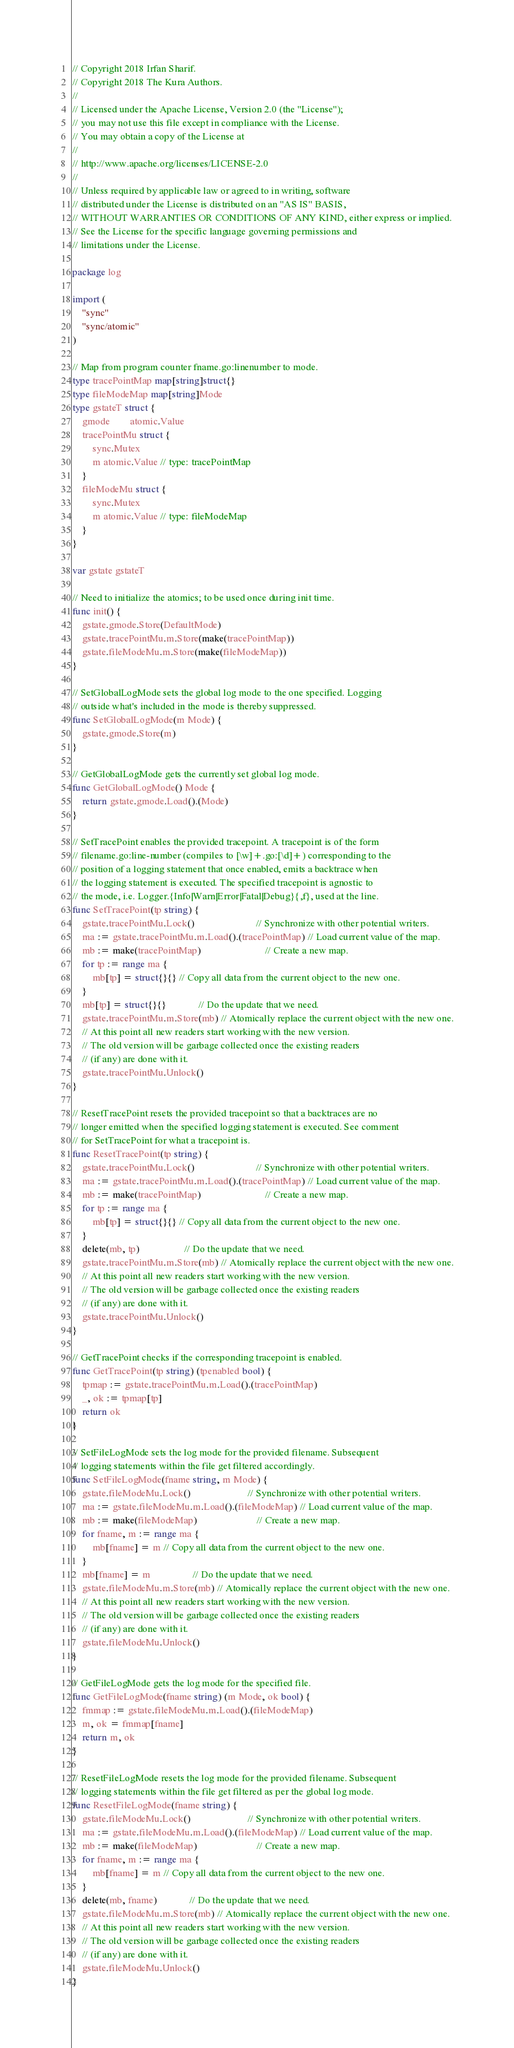<code> <loc_0><loc_0><loc_500><loc_500><_Go_>// Copyright 2018 Irfan Sharif.
// Copyright 2018 The Kura Authors.
//
// Licensed under the Apache License, Version 2.0 (the "License");
// you may not use this file except in compliance with the License.
// You may obtain a copy of the License at
//
// http://www.apache.org/licenses/LICENSE-2.0
//
// Unless required by applicable law or agreed to in writing, software
// distributed under the License is distributed on an "AS IS" BASIS,
// WITHOUT WARRANTIES OR CONDITIONS OF ANY KIND, either express or implied.
// See the License for the specific language governing permissions and
// limitations under the License.

package log

import (
	"sync"
	"sync/atomic"
)

// Map from program counter fname.go:linenumber to mode.
type tracePointMap map[string]struct{}
type fileModeMap map[string]Mode
type gstateT struct {
	gmode        atomic.Value
	tracePointMu struct {
		sync.Mutex
		m atomic.Value // type: tracePointMap
	}
	fileModeMu struct {
		sync.Mutex
		m atomic.Value // type: fileModeMap
	}
}

var gstate gstateT

// Need to initialize the atomics; to be used once during init time.
func init() {
	gstate.gmode.Store(DefaultMode)
	gstate.tracePointMu.m.Store(make(tracePointMap))
	gstate.fileModeMu.m.Store(make(fileModeMap))
}

// SetGlobalLogMode sets the global log mode to the one specified. Logging
// outside what's included in the mode is thereby suppressed.
func SetGlobalLogMode(m Mode) {
	gstate.gmode.Store(m)
}

// GetGlobalLogMode gets the currently set global log mode.
func GetGlobalLogMode() Mode {
	return gstate.gmode.Load().(Mode)
}

// SetTracePoint enables the provided tracepoint. A tracepoint is of the form
// filename.go:line-number (compiles to [\w]+.go:[\d]+) corresponding to the
// position of a logging statement that once enabled, emits a backtrace when
// the logging statement is executed. The specified tracepoint is agnostic to
// the mode, i.e. Logger.{Info|Warn|Error|Fatal|Debug}{,f}, used at the line.
func SetTracePoint(tp string) {
	gstate.tracePointMu.Lock()                         // Synchronize with other potential writers.
	ma := gstate.tracePointMu.m.Load().(tracePointMap) // Load current value of the map.
	mb := make(tracePointMap)                          // Create a new map.
	for tp := range ma {
		mb[tp] = struct{}{} // Copy all data from the current object to the new one.
	}
	mb[tp] = struct{}{}             // Do the update that we need.
	gstate.tracePointMu.m.Store(mb) // Atomically replace the current object with the new one.
	// At this point all new readers start working with the new version.
	// The old version will be garbage collected once the existing readers
	// (if any) are done with it.
	gstate.tracePointMu.Unlock()
}

// ResetTracePoint resets the provided tracepoint so that a backtraces are no
// longer emitted when the specified logging statement is executed. See comment
// for SetTracePoint for what a tracepoint is.
func ResetTracePoint(tp string) {
	gstate.tracePointMu.Lock()                         // Synchronize with other potential writers.
	ma := gstate.tracePointMu.m.Load().(tracePointMap) // Load current value of the map.
	mb := make(tracePointMap)                          // Create a new map.
	for tp := range ma {
		mb[tp] = struct{}{} // Copy all data from the current object to the new one.
	}
	delete(mb, tp)                  // Do the update that we need.
	gstate.tracePointMu.m.Store(mb) // Atomically replace the current object with the new one.
	// At this point all new readers start working with the new version.
	// The old version will be garbage collected once the existing readers
	// (if any) are done with it.
	gstate.tracePointMu.Unlock()
}

// GetTracePoint checks if the corresponding tracepoint is enabled.
func GetTracePoint(tp string) (tpenabled bool) {
	tpmap := gstate.tracePointMu.m.Load().(tracePointMap)
	_, ok := tpmap[tp]
	return ok
}

// SetFileLogMode sets the log mode for the provided filename. Subsequent
// logging statements within the file get filtered accordingly.
func SetFileLogMode(fname string, m Mode) {
	gstate.fileModeMu.Lock()                       // Synchronize with other potential writers.
	ma := gstate.fileModeMu.m.Load().(fileModeMap) // Load current value of the map.
	mb := make(fileModeMap)                        // Create a new map.
	for fname, m := range ma {
		mb[fname] = m // Copy all data from the current object to the new one.
	}
	mb[fname] = m                 // Do the update that we need.
	gstate.fileModeMu.m.Store(mb) // Atomically replace the current object with the new one.
	// At this point all new readers start working with the new version.
	// The old version will be garbage collected once the existing readers
	// (if any) are done with it.
	gstate.fileModeMu.Unlock()
}

// GetFileLogMode gets the log mode for the specified file.
func GetFileLogMode(fname string) (m Mode, ok bool) {
	fmmap := gstate.fileModeMu.m.Load().(fileModeMap)
	m, ok = fmmap[fname]
	return m, ok
}

// ResetFileLogMode resets the log mode for the provided filename. Subsequent
// logging statements within the file get filtered as per the global log mode.
func ResetFileLogMode(fname string) {
	gstate.fileModeMu.Lock()                       // Synchronize with other potential writers.
	ma := gstate.fileModeMu.m.Load().(fileModeMap) // Load current value of the map.
	mb := make(fileModeMap)                        // Create a new map.
	for fname, m := range ma {
		mb[fname] = m // Copy all data from the current object to the new one.
	}
	delete(mb, fname)             // Do the update that we need.
	gstate.fileModeMu.m.Store(mb) // Atomically replace the current object with the new one.
	// At this point all new readers start working with the new version.
	// The old version will be garbage collected once the existing readers
	// (if any) are done with it.
	gstate.fileModeMu.Unlock()
}
</code> 